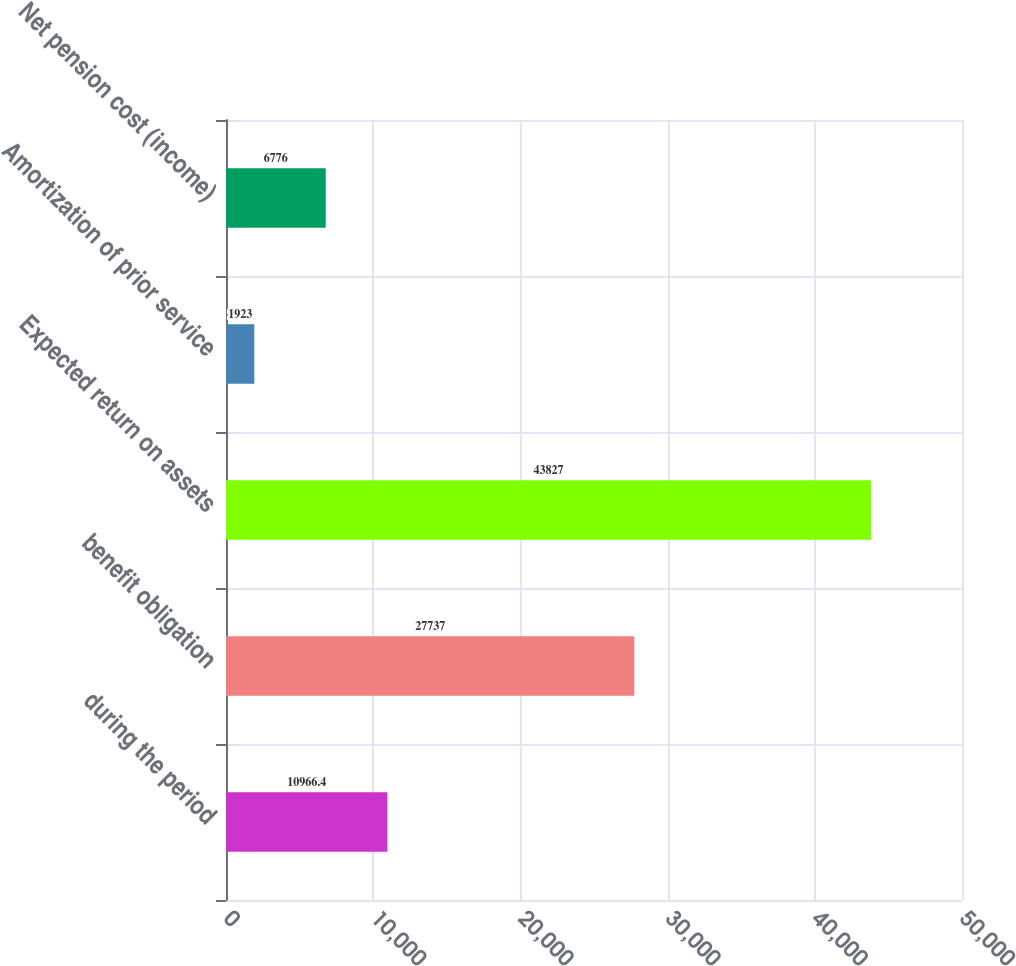Convert chart to OTSL. <chart><loc_0><loc_0><loc_500><loc_500><bar_chart><fcel>during the period<fcel>benefit obligation<fcel>Expected return on assets<fcel>Amortization of prior service<fcel>Net pension cost (income)<nl><fcel>10966.4<fcel>27737<fcel>43827<fcel>1923<fcel>6776<nl></chart> 